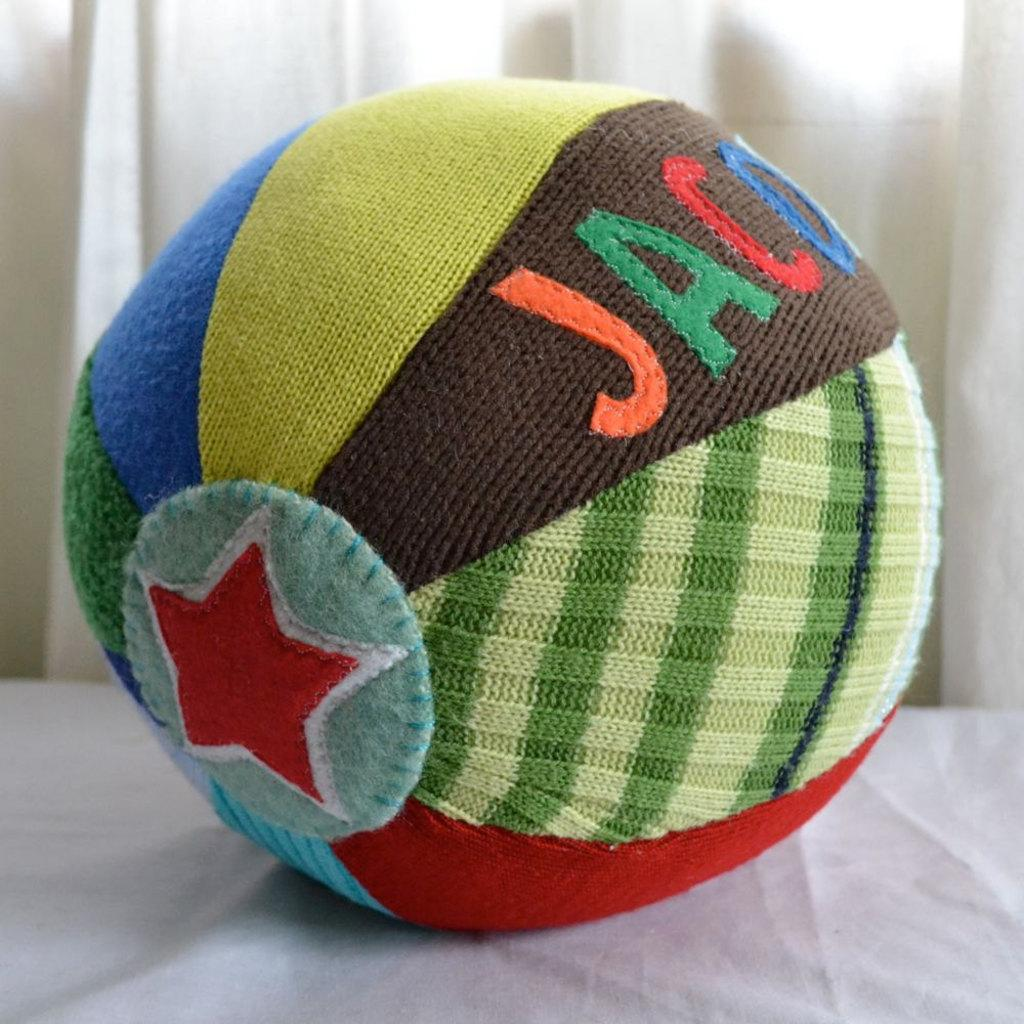What is the main object in the center of the image? There is a ball in the center of the image. What surface is the ball resting on? There appears to be a table at the bottom of the image. What can be seen in the background of the image? There is a curtain in the background of the image. What type of eye is visible on the ball in the image? There is no eye visible on the ball in the image. What form of protest is taking place in the image? There is no protest or any indication of protest in the image. 